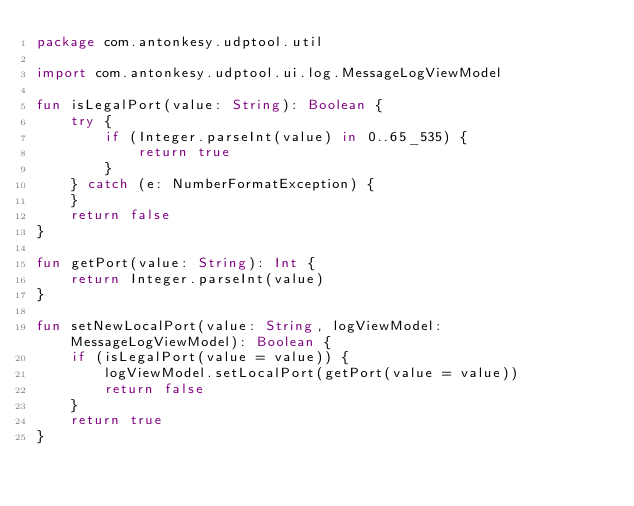<code> <loc_0><loc_0><loc_500><loc_500><_Kotlin_>package com.antonkesy.udptool.util

import com.antonkesy.udptool.ui.log.MessageLogViewModel

fun isLegalPort(value: String): Boolean {
    try {
        if (Integer.parseInt(value) in 0..65_535) {
            return true
        }
    } catch (e: NumberFormatException) {
    }
    return false
}

fun getPort(value: String): Int {
    return Integer.parseInt(value)
}

fun setNewLocalPort(value: String, logViewModel: MessageLogViewModel): Boolean {
    if (isLegalPort(value = value)) {
        logViewModel.setLocalPort(getPort(value = value))
        return false
    }
    return true
}
</code> 